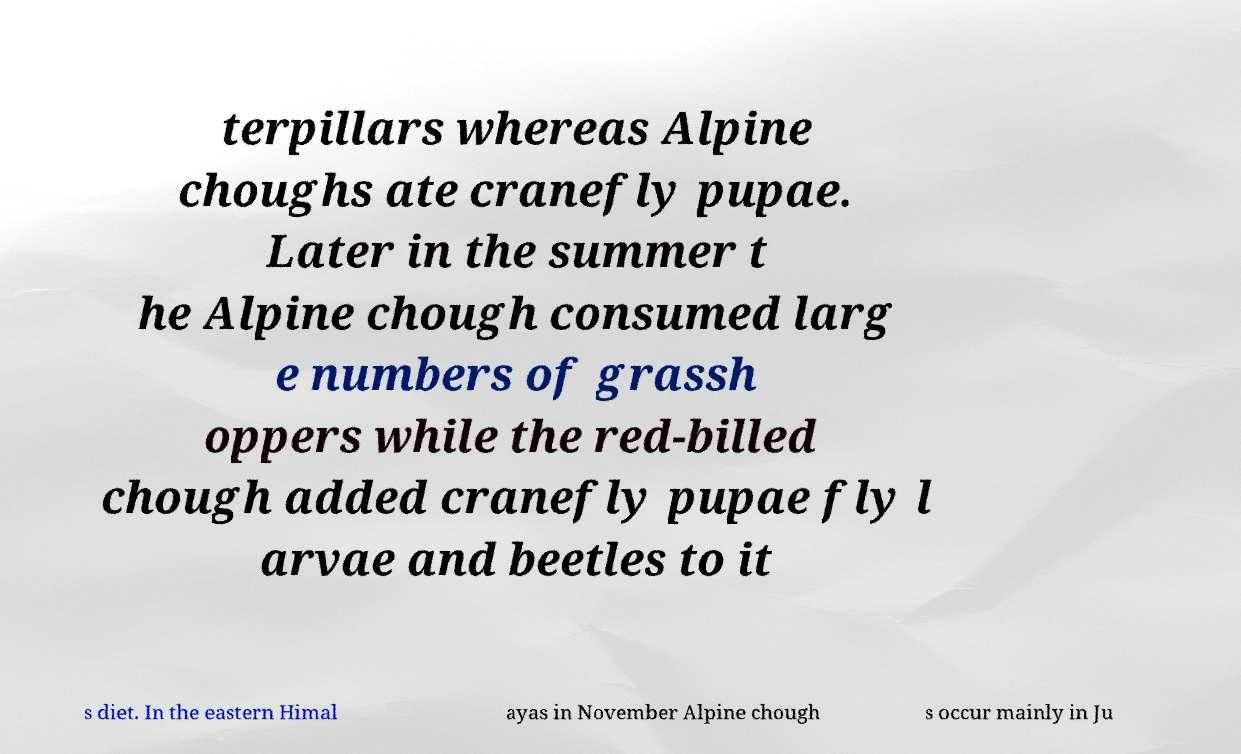Please read and relay the text visible in this image. What does it say? terpillars whereas Alpine choughs ate cranefly pupae. Later in the summer t he Alpine chough consumed larg e numbers of grassh oppers while the red-billed chough added cranefly pupae fly l arvae and beetles to it s diet. In the eastern Himal ayas in November Alpine chough s occur mainly in Ju 